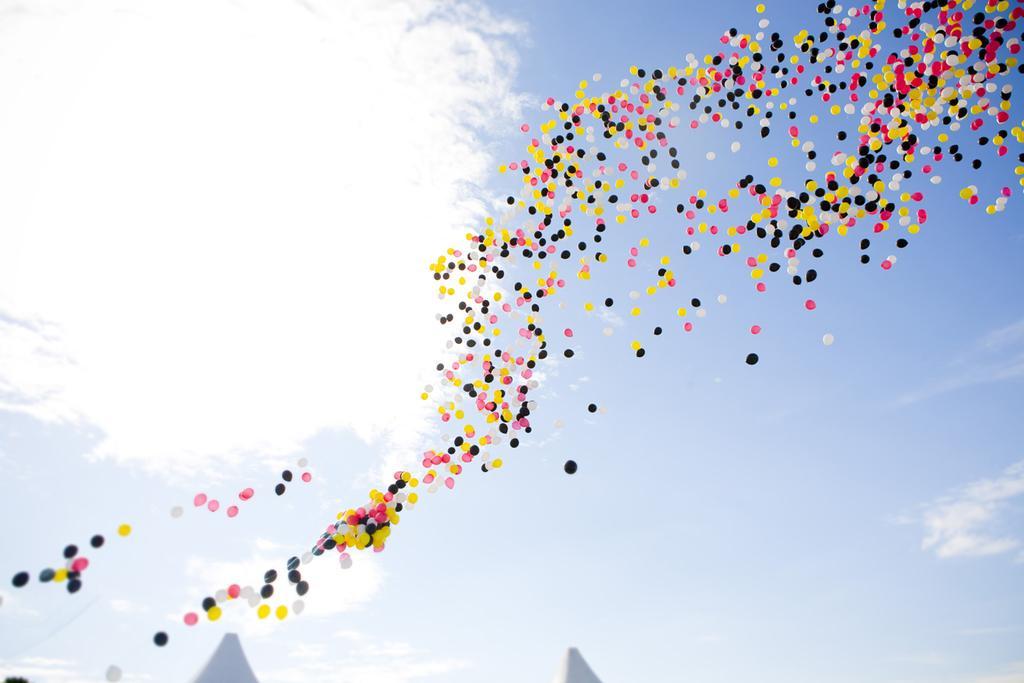Describe this image in one or two sentences. In this image I can see the balloons. In the background, I can see the clouds in the sky. 